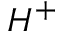<formula> <loc_0><loc_0><loc_500><loc_500>H ^ { + }</formula> 